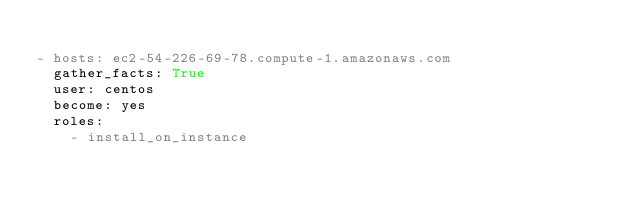Convert code to text. <code><loc_0><loc_0><loc_500><loc_500><_YAML_>
- hosts: ec2-54-226-69-78.compute-1.amazonaws.com
  gather_facts: True
  user: centos
  become: yes
  roles:
    - install_on_instance
</code> 